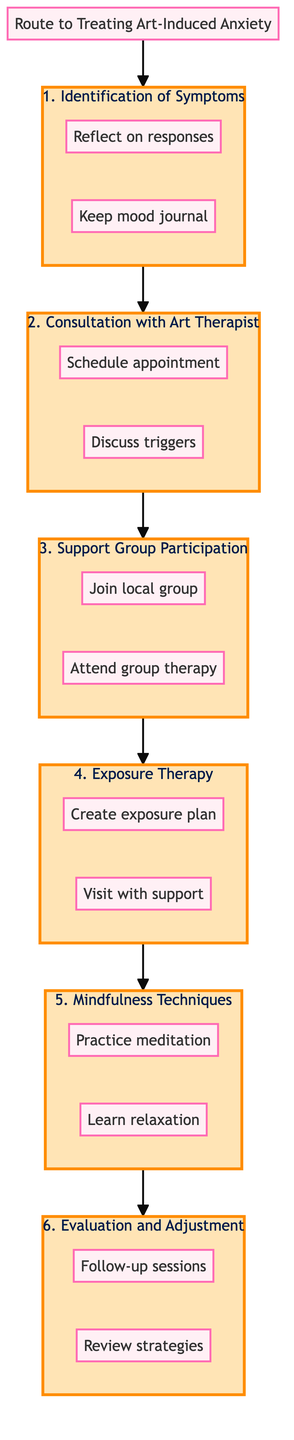What is the title of the diagram? The title of the diagram is stated at the top, presenting the main theme of the content. It clearly indicates the overall purpose of the diagram: “Route to Treating Art-Induced Anxiety - Steps for Recognition and Support.”
Answer: Route to Treating Art-Induced Anxiety - Steps for Recognition and Support How many steps are there in the clinical pathway? The diagram shows a total of six distinct steps listed sequentially from 1 to 6. Each step is labeled clearly within the flowchart structure.
Answer: 6 What is the action associated with step 3? In step 3, there are two specific actions outlined: "Join local group" and "Attend group therapy." These actions represent the approach to overcoming art-induced anxiety through community support.
Answer: Join local group, Attend group therapy What type of therapy is recommended in step 2? Step 2 emphasizes the importance of “Consultation with Art Therapist,” focusing on professional guidance in addressing anxiety triggers related to art. This indicates the specific type of support being sought.
Answer: Consultation with Art Therapist What step precedes Mindfulness and Relaxation Techniques? Referring to the flowchart layout, “Exposure Therapy” is the step that comes directly before “Mindfulness and Relaxation Techniques,” indicating the progression in treatment strategy.
Answer: Exposure Therapy Describe the main purpose of step 6. The description of step 6 is "Evaluation and Adjustment." This implies that the main goal here is to assess the effectiveness of the treatment and to make modifications as necessary for continuous improvement.
Answer: Evaluation and Adjustment What are the two actions in step 5? In step 5, the actions indicated are: "Practice meditation" and "Learn relaxation." These actions are crucial for managing anxiety through mindfulness and relaxation techniques tailored to art experiences.
Answer: Practice meditation, Learn relaxation What comes after Support Group Participation? Following the flow of the diagram, step 4 “Exposure Therapy” is the next step that follows “Support Group Participation,” marking a shift to more focused therapeutic interventions.
Answer: Exposure Therapy How is “Identification of Symptoms” evaluated? In the diagram, this step leads to personal reflection and journaling as means of evaluation, providing a subjective way to identify and assess anxiety symptoms experienced in relation to art.
Answer: Reflect on responses, Keep mood journal 